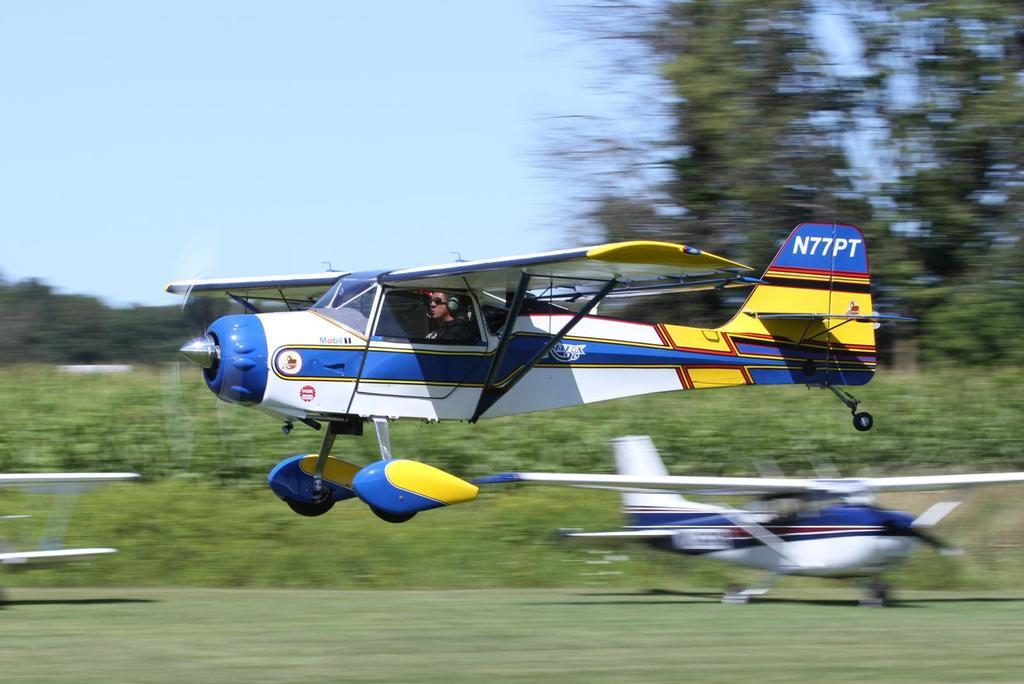How many aircrafts are present in the image? There are 3 aircrafts in the image. What type of vegetation can be seen in the image? There is grass, plants, and trees visible in the image. What is visible in the background of the image? The sky is visible in the background of the image. Can you describe the quality of the image? The image is a bit blurry. What type of shoes can be seen on the aircrafts in the image? There are no shoes visible in the image; it features 3 aircrafts, grass, plants, trees, and a sky background. How much sugar is present in the image? There is no sugar present in the image; it is a photograph of 3 aircrafts, grass, plants, trees, and a sky background. 